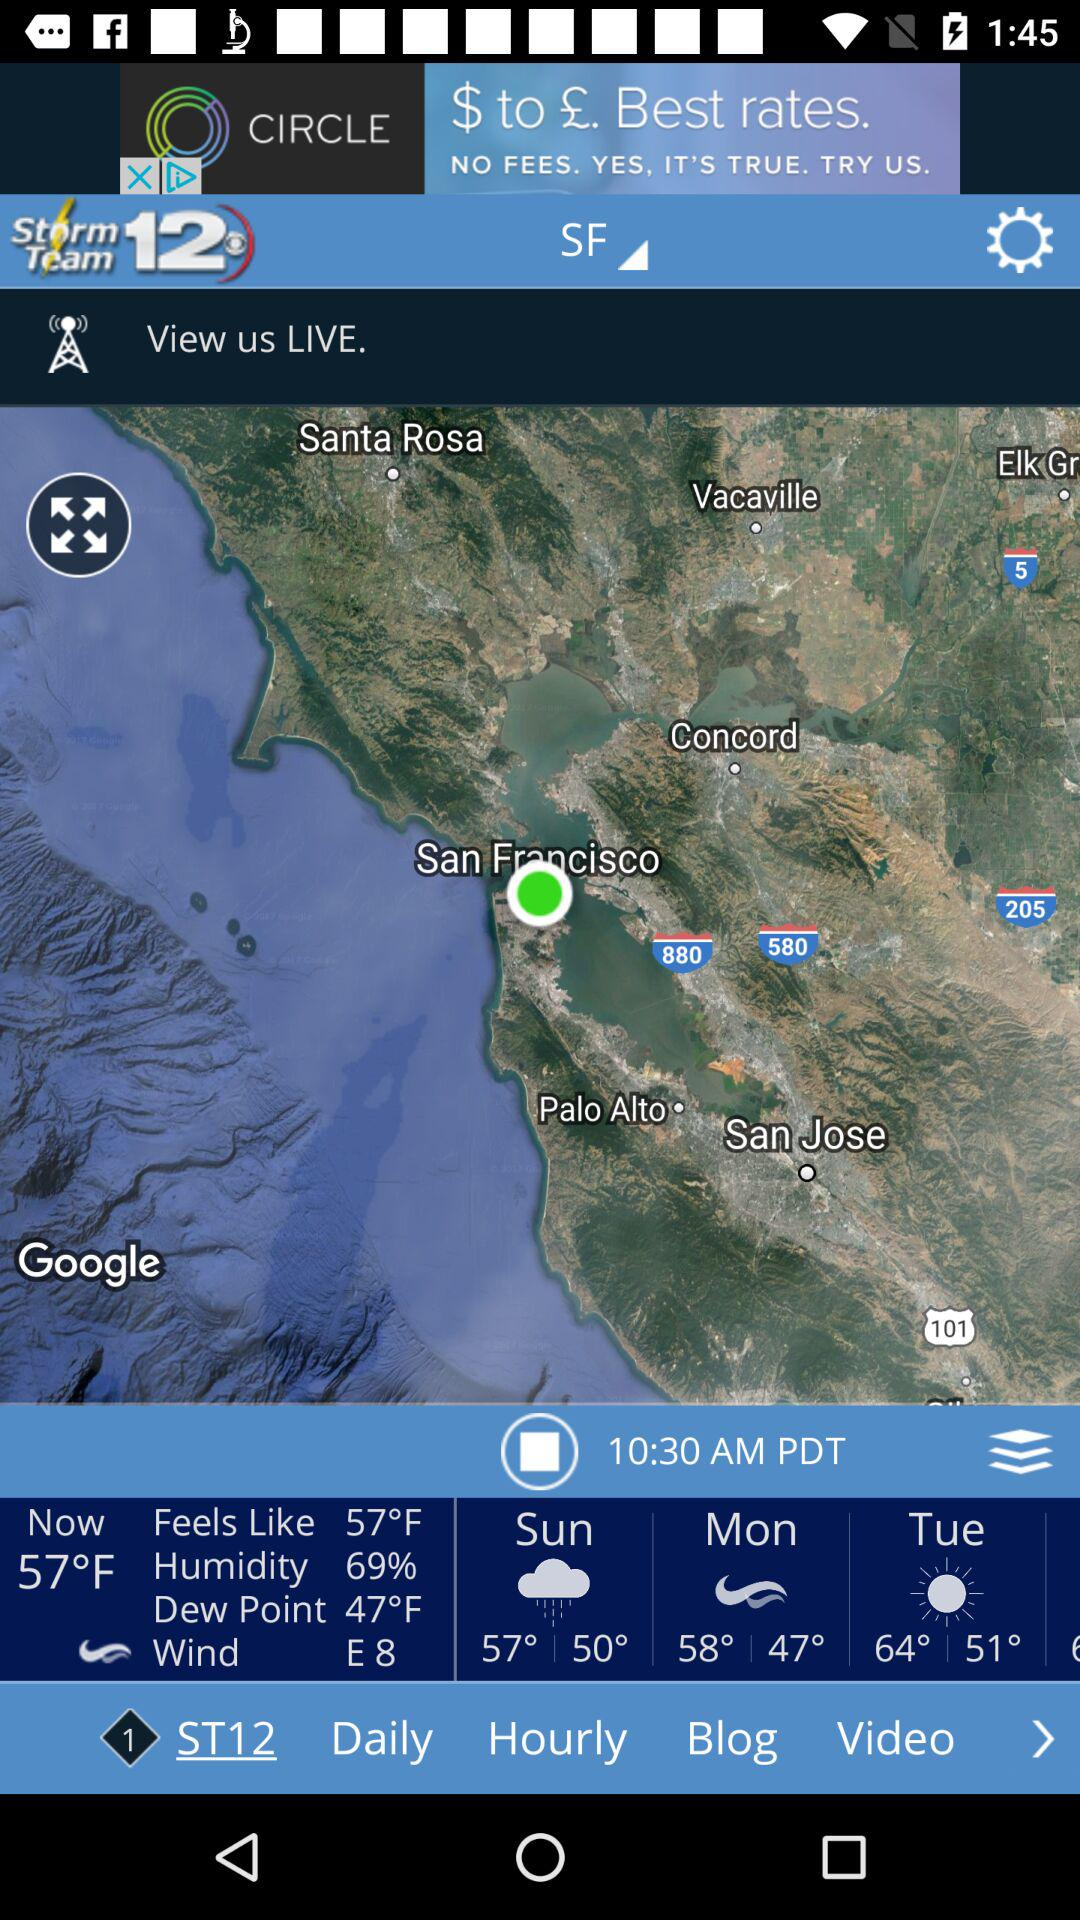How many degrees Fahrenheit is the current temperature?
Answer the question using a single word or phrase. 57°F 